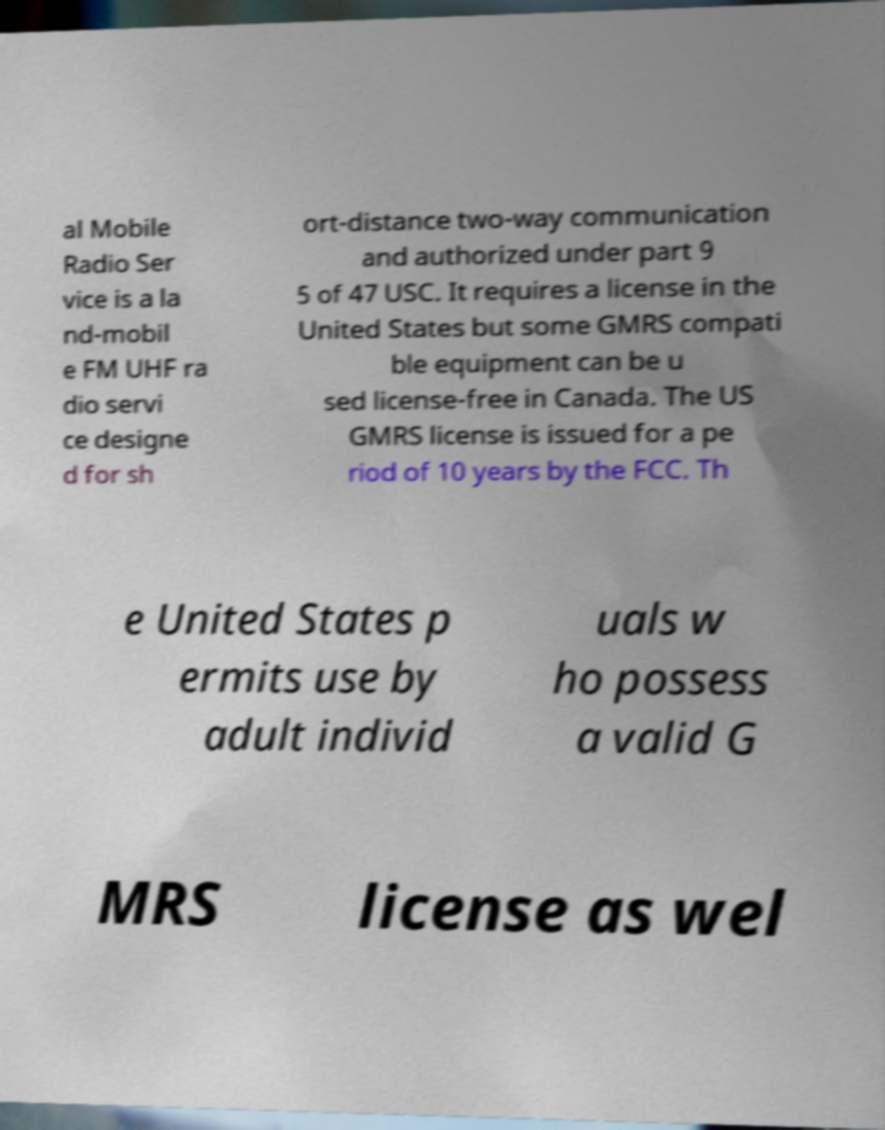Could you assist in decoding the text presented in this image and type it out clearly? al Mobile Radio Ser vice is a la nd-mobil e FM UHF ra dio servi ce designe d for sh ort-distance two-way communication and authorized under part 9 5 of 47 USC. It requires a license in the United States but some GMRS compati ble equipment can be u sed license-free in Canada. The US GMRS license is issued for a pe riod of 10 years by the FCC. Th e United States p ermits use by adult individ uals w ho possess a valid G MRS license as wel 